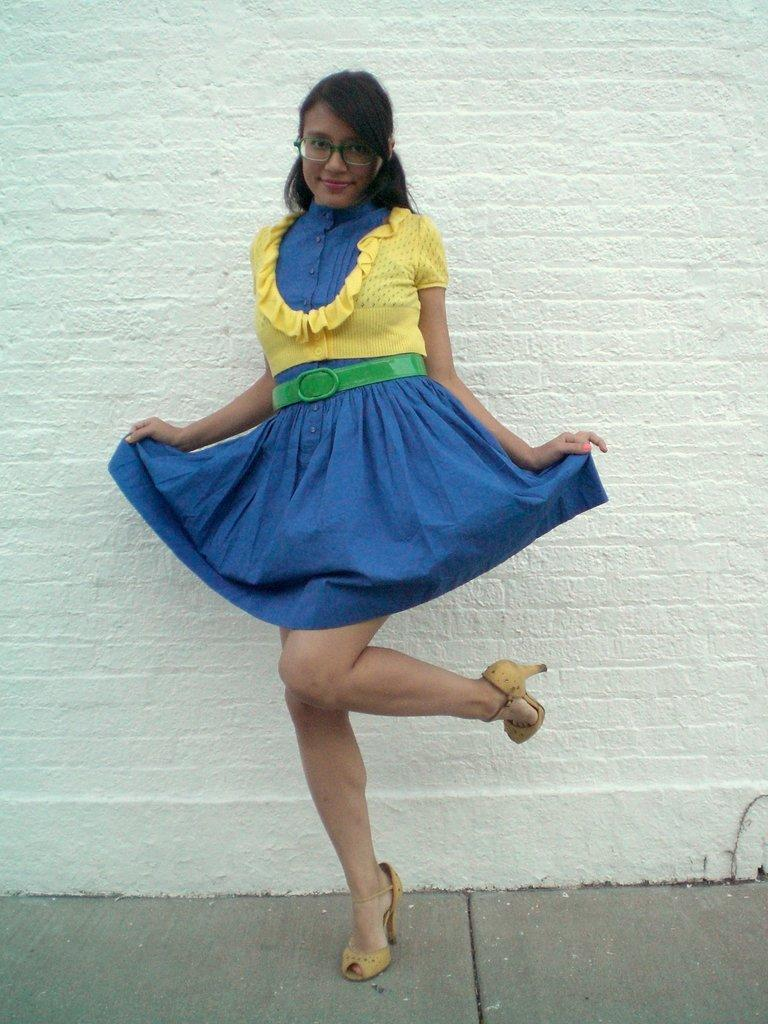Who or what is the main subject in the image? There is a person in the image. What is the person wearing? The person is wearing a yellow and blue color dress. What is the person's posture in the image? The person is standing. What can be seen in the background of the image? There is a wall in the background of the image. What type of sidewalk can be seen in the image? There is no sidewalk present in the image. 